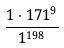<formula> <loc_0><loc_0><loc_500><loc_500>\frac { 1 \cdot 1 7 1 ^ { 9 } } { 1 ^ { 1 9 8 } }</formula> 